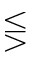<formula> <loc_0><loc_0><loc_500><loc_500>\leq s s e q g t r</formula> 